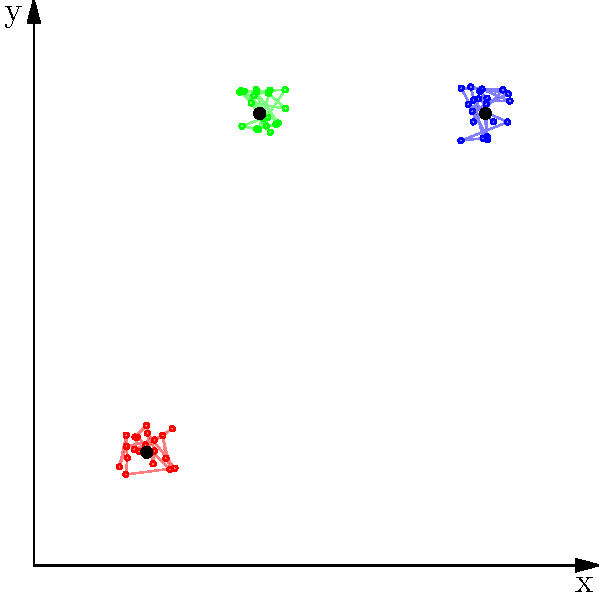In the visualization of K-means clustering results shown above, what can be inferred about the quality of the clustering based on the distribution of points and the positions of the cluster centers? To assess the quality of the K-means clustering results, we need to analyze several aspects of the visualization:

1. Separation between clusters:
   - The clusters appear to be relatively well-separated, with minimal overlap between different colored point groups.
   - This suggests good inter-cluster separation, which is a positive indicator of clustering quality.

2. Compactness within clusters:
   - Each cluster (red, blue, and green) shows a relatively tight grouping of points around its center.
   - This indicates good intra-cluster cohesion, another positive sign of clustering quality.

3. Position of cluster centers:
   - The black dots representing cluster centers are positioned near the center of their respective point clouds.
   - This suggests that the algorithm has converged to reasonable centroid positions.

4. Shape and size of clusters:
   - The clusters appear to be roughly circular and of similar size.
   - This is consistent with the K-means assumption of spherical clusters with equal variances.

5. Number of clusters:
   - The presence of three distinct clusters aligns with the use of K=3 in the K-means algorithm.
   - The clear separation supports the choice of K=3 as an appropriate number of clusters for this dataset.

6. Outliers and noise:
   - There don't appear to be significant outliers or noise points far from the cluster centers.
   - This suggests that most data points fit well into one of the three clusters.

7. Cluster balance:
   - The clusters seem to have a similar number of points, indicating a relatively balanced clustering.

Given these observations, we can conclude that the K-means clustering has performed well on this dataset, producing well-defined, separated clusters with centroids that accurately represent their respective groups.
Answer: High-quality clustering with well-separated, compact clusters and appropriately positioned centroids 